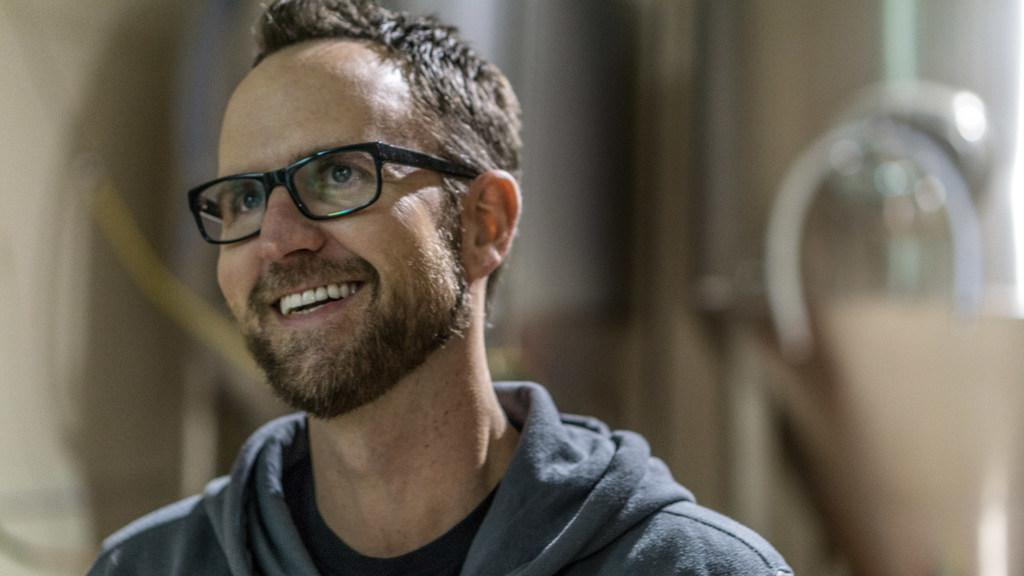What can be seen in the image? There is a person in the image. How is the person's expression? The person is smiling. What accessory is the person wearing? The person is wearing spectacles. Can you describe the background of the image? The background of the image is blurry. What language is the person speaking in the image? There is no indication of the person speaking in the image, so it cannot be determined which language they might be using. 